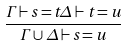Convert formula to latex. <formula><loc_0><loc_0><loc_500><loc_500>\frac { \Gamma \vdash s = t \Delta \vdash t = u } { \Gamma \cup \Delta \vdash s = u }</formula> 